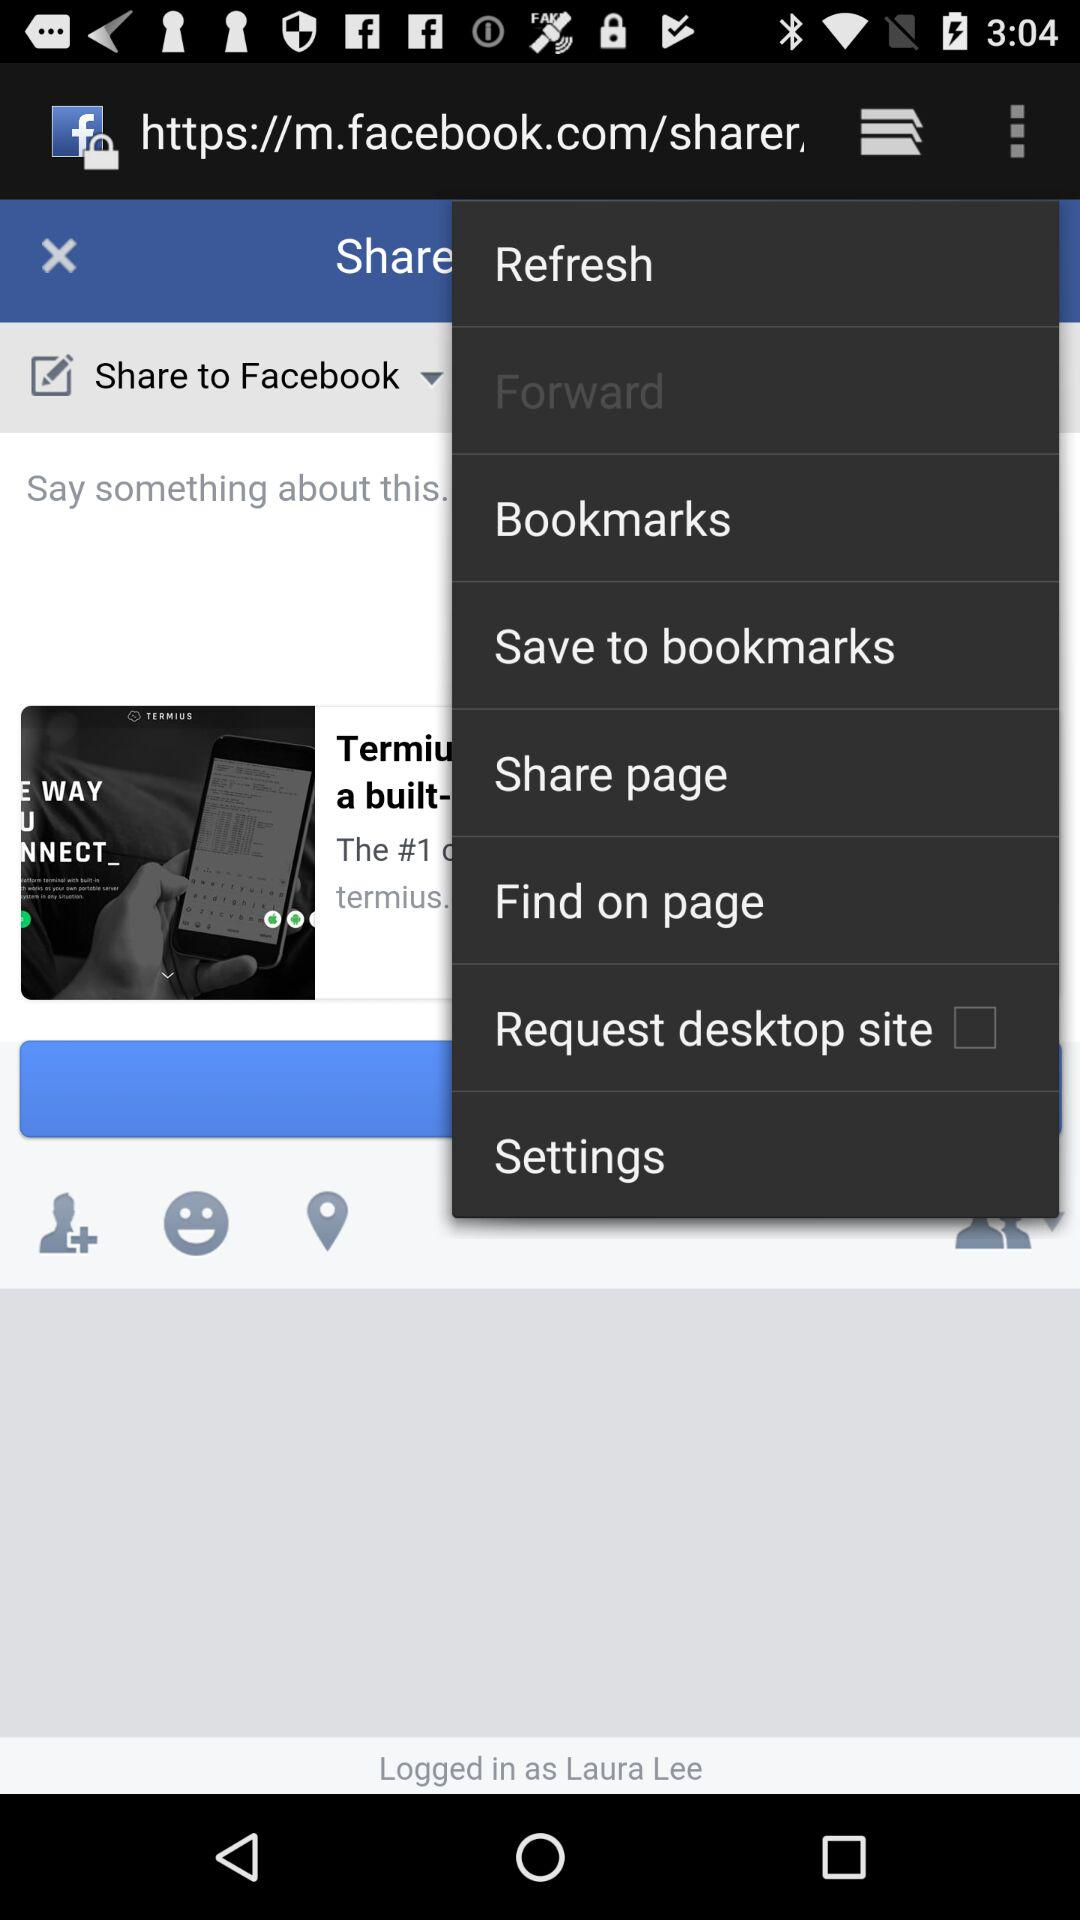What is the status of "Find on page"?
When the provided information is insufficient, respond with <no answer>. <no answer> 